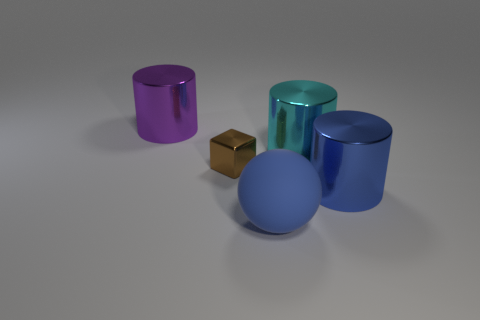Is there anything else that has the same shape as the tiny thing?
Ensure brevity in your answer.  No. Is there anything else that has the same size as the brown metal thing?
Provide a succinct answer. No. Do the thing that is in front of the blue metallic thing and the shiny thing that is in front of the small brown metal block have the same color?
Your response must be concise. Yes. There is a big blue thing that is behind the object that is in front of the large blue cylinder; what number of metallic cylinders are on the left side of it?
Offer a terse response. 2. What number of cylinders are on the left side of the large matte sphere and on the right side of the sphere?
Offer a very short reply. 0. Are there more big shiny cylinders that are to the left of the big blue cylinder than large cyan things?
Keep it short and to the point. Yes. What number of red shiny cubes have the same size as the blue shiny cylinder?
Offer a very short reply. 0. What number of tiny objects are either matte spheres or brown metallic blocks?
Provide a short and direct response. 1. What number of yellow spheres are there?
Make the answer very short. 0. Is the number of cyan cylinders that are behind the large blue matte thing the same as the number of large purple metallic cylinders that are behind the big cyan metal cylinder?
Give a very brief answer. Yes. 